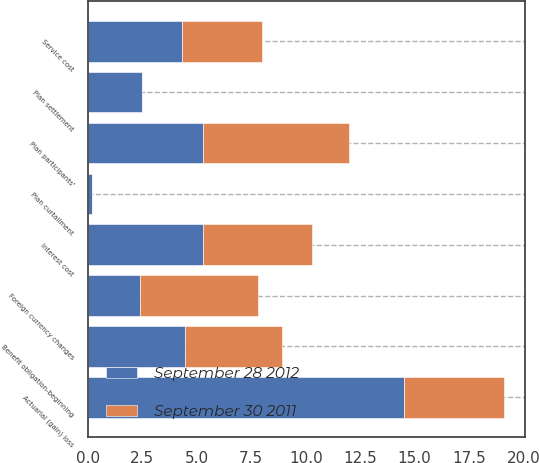Convert chart. <chart><loc_0><loc_0><loc_500><loc_500><stacked_bar_chart><ecel><fcel>Benefit obligation-beginning<fcel>Service cost<fcel>Interest cost<fcel>Plan participants'<fcel>Plan settlement<fcel>Plan curtailment<fcel>Actuarial (gain) loss<fcel>Foreign currency changes<nl><fcel>September 28 2012<fcel>4.45<fcel>4.3<fcel>5.3<fcel>5.3<fcel>2.5<fcel>0.2<fcel>14.5<fcel>2.4<nl><fcel>September 30 2011<fcel>4.45<fcel>3.7<fcel>5<fcel>6.7<fcel>0<fcel>0<fcel>4.6<fcel>5.4<nl></chart> 